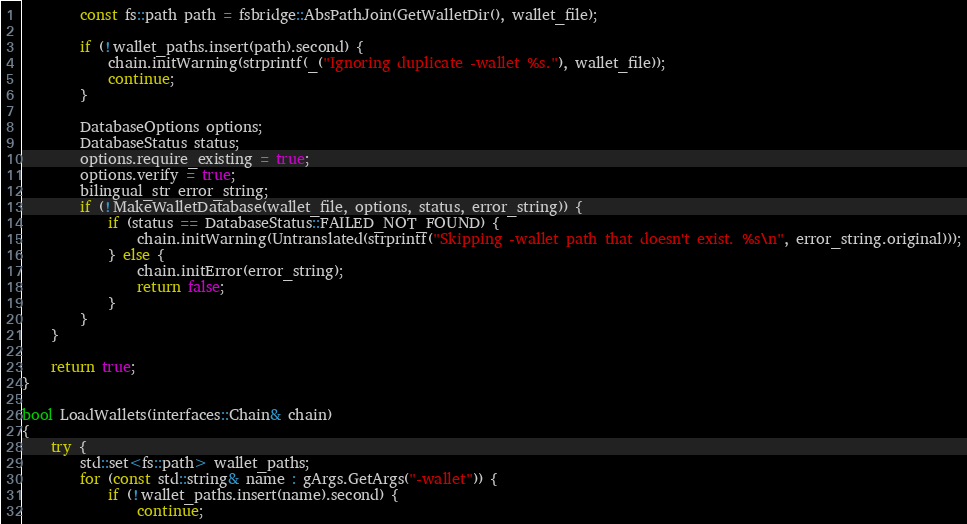<code> <loc_0><loc_0><loc_500><loc_500><_C++_>        const fs::path path = fsbridge::AbsPathJoin(GetWalletDir(), wallet_file);

        if (!wallet_paths.insert(path).second) {
            chain.initWarning(strprintf(_("Ignoring duplicate -wallet %s."), wallet_file));
            continue;
        }

        DatabaseOptions options;
        DatabaseStatus status;
        options.require_existing = true;
        options.verify = true;
        bilingual_str error_string;
        if (!MakeWalletDatabase(wallet_file, options, status, error_string)) {
            if (status == DatabaseStatus::FAILED_NOT_FOUND) {
                chain.initWarning(Untranslated(strprintf("Skipping -wallet path that doesn't exist. %s\n", error_string.original)));
            } else {
                chain.initError(error_string);
                return false;
            }
        }
    }

    return true;
}

bool LoadWallets(interfaces::Chain& chain)
{
    try {
        std::set<fs::path> wallet_paths;
        for (const std::string& name : gArgs.GetArgs("-wallet")) {
            if (!wallet_paths.insert(name).second) {
                continue;</code> 